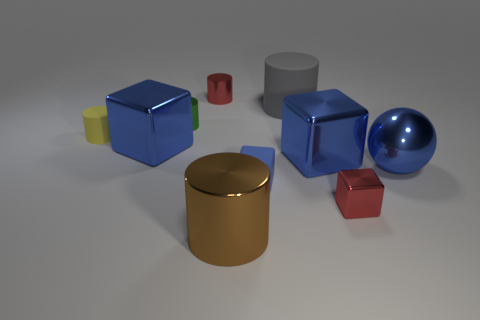Subtract all red spheres. How many blue cubes are left? 3 Subtract all yellow cylinders. How many cylinders are left? 4 Subtract 1 blocks. How many blocks are left? 3 Subtract all large brown cylinders. How many cylinders are left? 4 Subtract all gray cylinders. Subtract all gray spheres. How many cylinders are left? 4 Subtract all cubes. How many objects are left? 6 Add 6 shiny cylinders. How many shiny cylinders are left? 9 Add 3 small objects. How many small objects exist? 8 Subtract 0 green blocks. How many objects are left? 10 Subtract all small cylinders. Subtract all shiny cylinders. How many objects are left? 4 